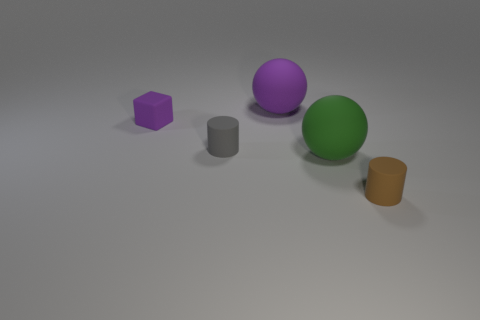Are the small purple block and the sphere in front of the gray matte object made of the same material?
Offer a terse response. Yes. The other thing that is the same shape as the green thing is what size?
Your answer should be very brief. Large. Are there the same number of cylinders in front of the green sphere and large green things on the left side of the gray rubber object?
Give a very brief answer. No. How many other objects are the same material as the small brown cylinder?
Offer a very short reply. 4. Is the number of purple blocks that are right of the tiny brown thing the same as the number of large purple objects?
Offer a terse response. No. There is a purple ball; is its size the same as the ball that is in front of the small cube?
Offer a very short reply. Yes. What shape is the tiny gray object behind the brown rubber thing?
Give a very brief answer. Cylinder. Are there any other things that have the same shape as the tiny purple object?
Your response must be concise. No. Are there any tiny cyan metallic spheres?
Make the answer very short. No. Does the gray rubber cylinder that is to the left of the green ball have the same size as the purple thing on the left side of the purple ball?
Your answer should be compact. Yes. 